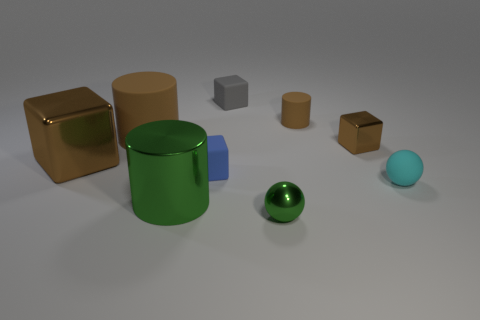Subtract all brown cylinders. How many were subtracted if there are1brown cylinders left? 1 Subtract all small blocks. How many blocks are left? 1 Subtract all blocks. How many objects are left? 5 Subtract 0 red spheres. How many objects are left? 9 Subtract 2 spheres. How many spheres are left? 0 Subtract all gray blocks. Subtract all cyan spheres. How many blocks are left? 3 Subtract all gray cubes. How many green spheres are left? 1 Subtract all large green cylinders. Subtract all tiny matte spheres. How many objects are left? 7 Add 3 shiny blocks. How many shiny blocks are left? 5 Add 9 green balls. How many green balls exist? 10 